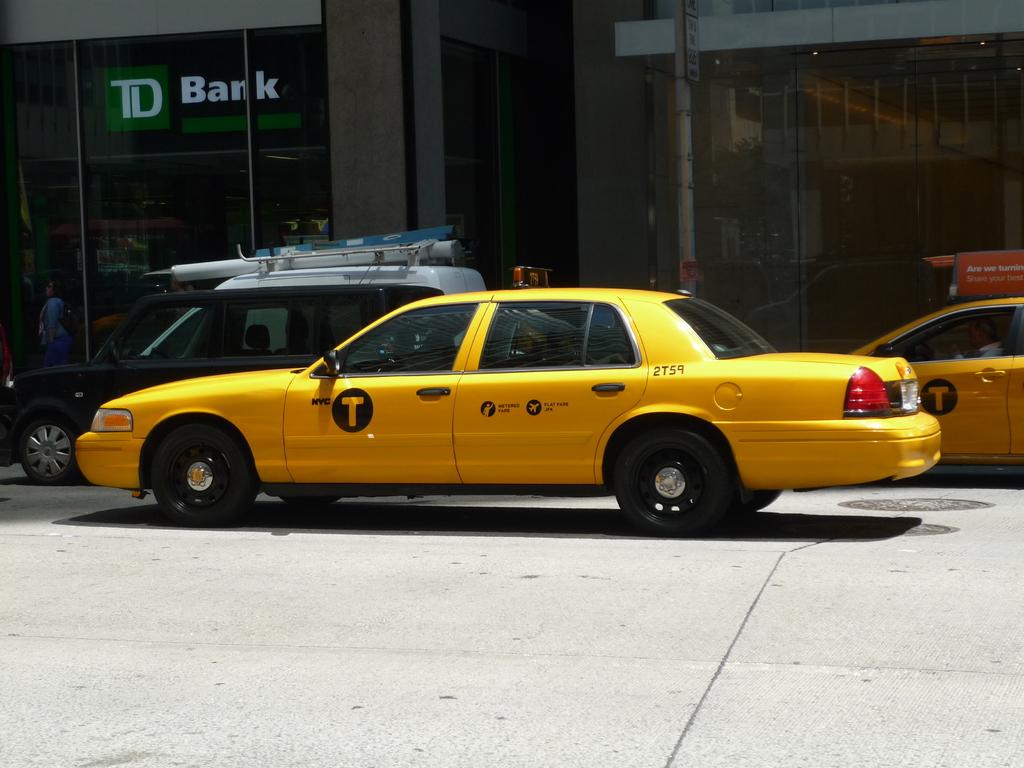What bank is in the photo?
Provide a short and direct response. Td bank. What is the taxi number?
Your response must be concise. 2t59. 